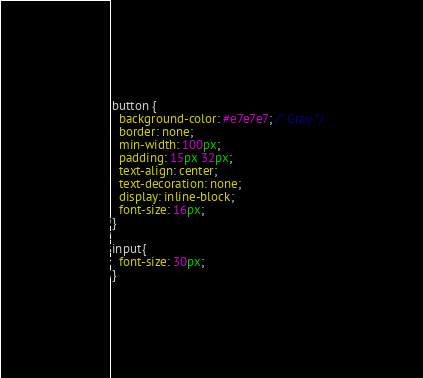Convert code to text. <code><loc_0><loc_0><loc_500><loc_500><_CSS_>
button {
  background-color: #e7e7e7; /* Gray */
  border: none;
  min-width: 100px;
  padding: 15px 32px;
  text-align: center;
  text-decoration: none;
  display: inline-block;
  font-size: 16px;
}

input{
  font-size: 30px;
}
</code> 